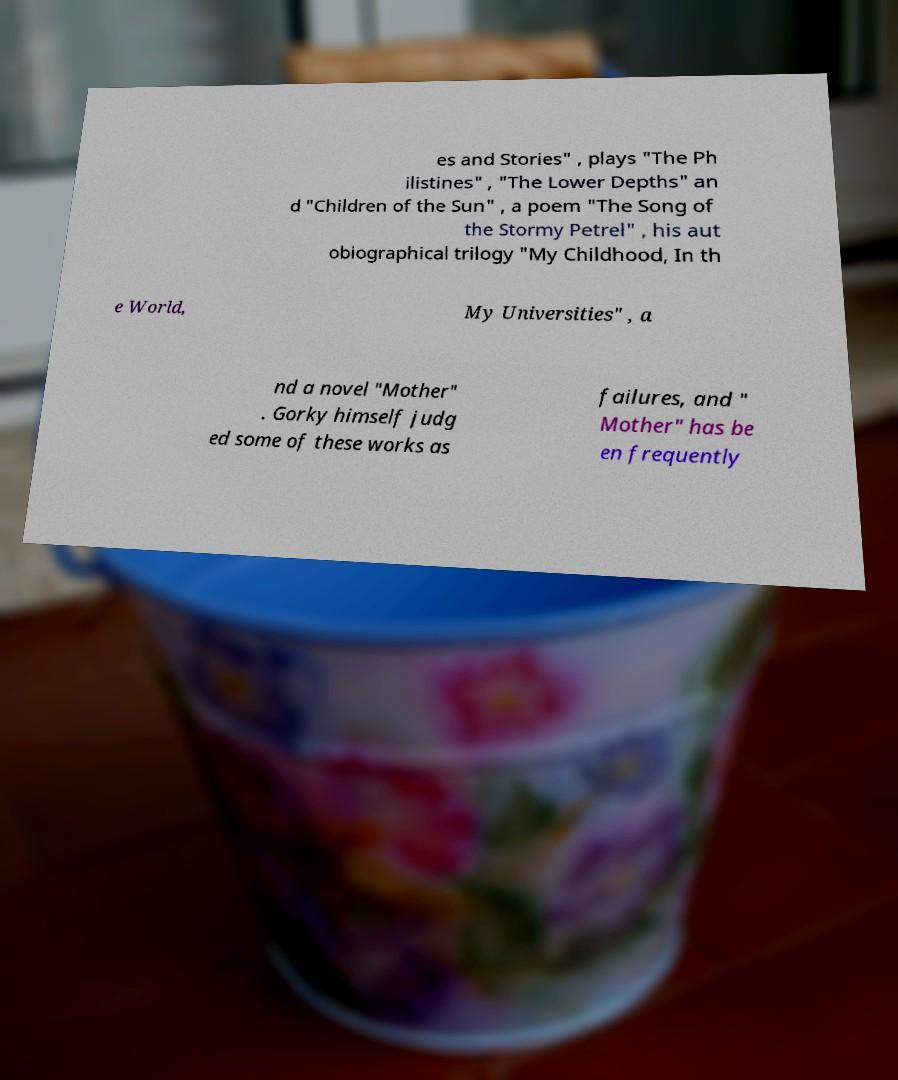I need the written content from this picture converted into text. Can you do that? es and Stories" , plays "The Ph ilistines" , "The Lower Depths" an d "Children of the Sun" , a poem "The Song of the Stormy Petrel" , his aut obiographical trilogy "My Childhood, In th e World, My Universities" , a nd a novel "Mother" . Gorky himself judg ed some of these works as failures, and " Mother" has be en frequently 